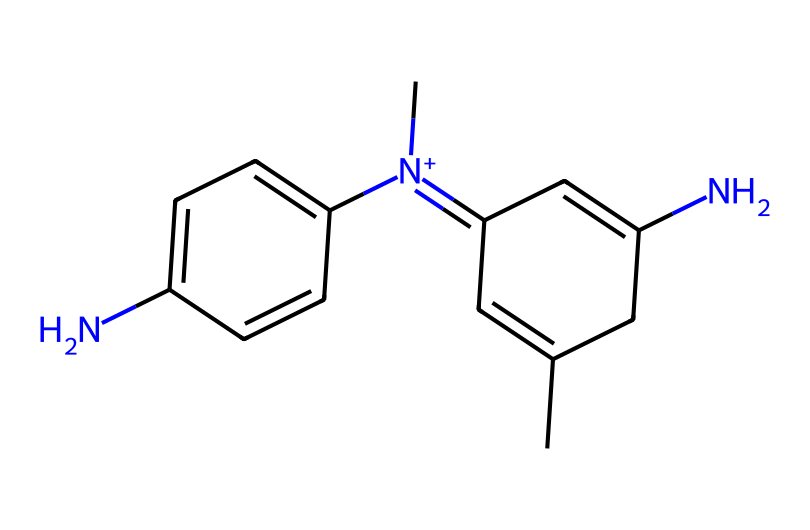What is the molecular formula of mauveine? By analyzing the SMILES representation, we can count the atoms present. The structure includes carbon (C) atoms, nitrogen (N) atoms, and hydrogen (H) atoms. After summing these, we find there are 18 carbon atoms, 20 hydrogen atoms, and 2 nitrogen atoms, which leads to the molecular formula C18H20N2.
Answer: C18H20N2 How many nitrogen atoms are in mauveine? By looking at the structure derived from the SMILES notation, we can identify the nitrogen atoms (N). In mauveine, there are 2 nitrogen atoms present.
Answer: 2 What type of chemical compound is mauveine? Given that mauveine is a synthetic dye with a complex aromatic structure and contains various functional groups, we classify it as a dye. More specifically, it's an azo dye due to the presence of nitrogen.
Answer: dye Which type of functional groups are present in mauveine? Reviewing the SMILES structure, we identify functional groups based on their connectivity. Mauveine contains amine groups (-NH2) as well as quaternary nitrogen. This characteristic indicates the presence of basic functional groups like amines or quaternary amines.
Answer: amine What is the degree of unsaturation in mauveine? Degree of unsaturation is calculated using the formula (1 + n/2 - h/2), where n is the number of carbons, and h is the number of hydrogens. For mauveine, n=18 and h=20, which results in a degree of unsaturation of 7. This indicates the presence of rings and/or double bonds in the structure.
Answer: 7 What color does mauveine produce when used as a dye? Historical records and chemical properties indicate that mauveine was known for producing a mauve or purple color, which is characteristic of the compound. Hence, it is often referred to as mauve dye.
Answer: mauve 